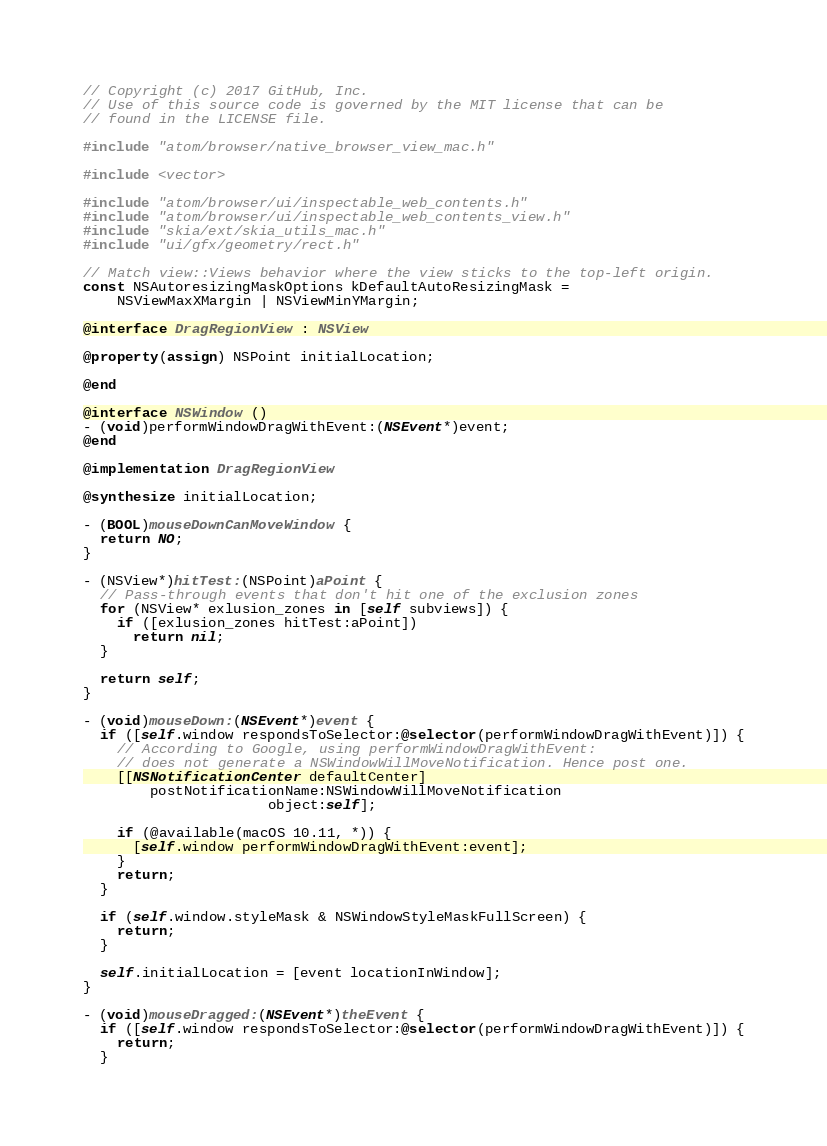Convert code to text. <code><loc_0><loc_0><loc_500><loc_500><_ObjectiveC_>// Copyright (c) 2017 GitHub, Inc.
// Use of this source code is governed by the MIT license that can be
// found in the LICENSE file.

#include "atom/browser/native_browser_view_mac.h"

#include <vector>

#include "atom/browser/ui/inspectable_web_contents.h"
#include "atom/browser/ui/inspectable_web_contents_view.h"
#include "skia/ext/skia_utils_mac.h"
#include "ui/gfx/geometry/rect.h"

// Match view::Views behavior where the view sticks to the top-left origin.
const NSAutoresizingMaskOptions kDefaultAutoResizingMask =
    NSViewMaxXMargin | NSViewMinYMargin;

@interface DragRegionView : NSView

@property(assign) NSPoint initialLocation;

@end

@interface NSWindow ()
- (void)performWindowDragWithEvent:(NSEvent*)event;
@end

@implementation DragRegionView

@synthesize initialLocation;

- (BOOL)mouseDownCanMoveWindow {
  return NO;
}

- (NSView*)hitTest:(NSPoint)aPoint {
  // Pass-through events that don't hit one of the exclusion zones
  for (NSView* exlusion_zones in [self subviews]) {
    if ([exlusion_zones hitTest:aPoint])
      return nil;
  }

  return self;
}

- (void)mouseDown:(NSEvent*)event {
  if ([self.window respondsToSelector:@selector(performWindowDragWithEvent)]) {
    // According to Google, using performWindowDragWithEvent:
    // does not generate a NSWindowWillMoveNotification. Hence post one.
    [[NSNotificationCenter defaultCenter]
        postNotificationName:NSWindowWillMoveNotification
                      object:self];

    if (@available(macOS 10.11, *)) {
      [self.window performWindowDragWithEvent:event];
    }
    return;
  }

  if (self.window.styleMask & NSWindowStyleMaskFullScreen) {
    return;
  }

  self.initialLocation = [event locationInWindow];
}

- (void)mouseDragged:(NSEvent*)theEvent {
  if ([self.window respondsToSelector:@selector(performWindowDragWithEvent)]) {
    return;
  }
</code> 